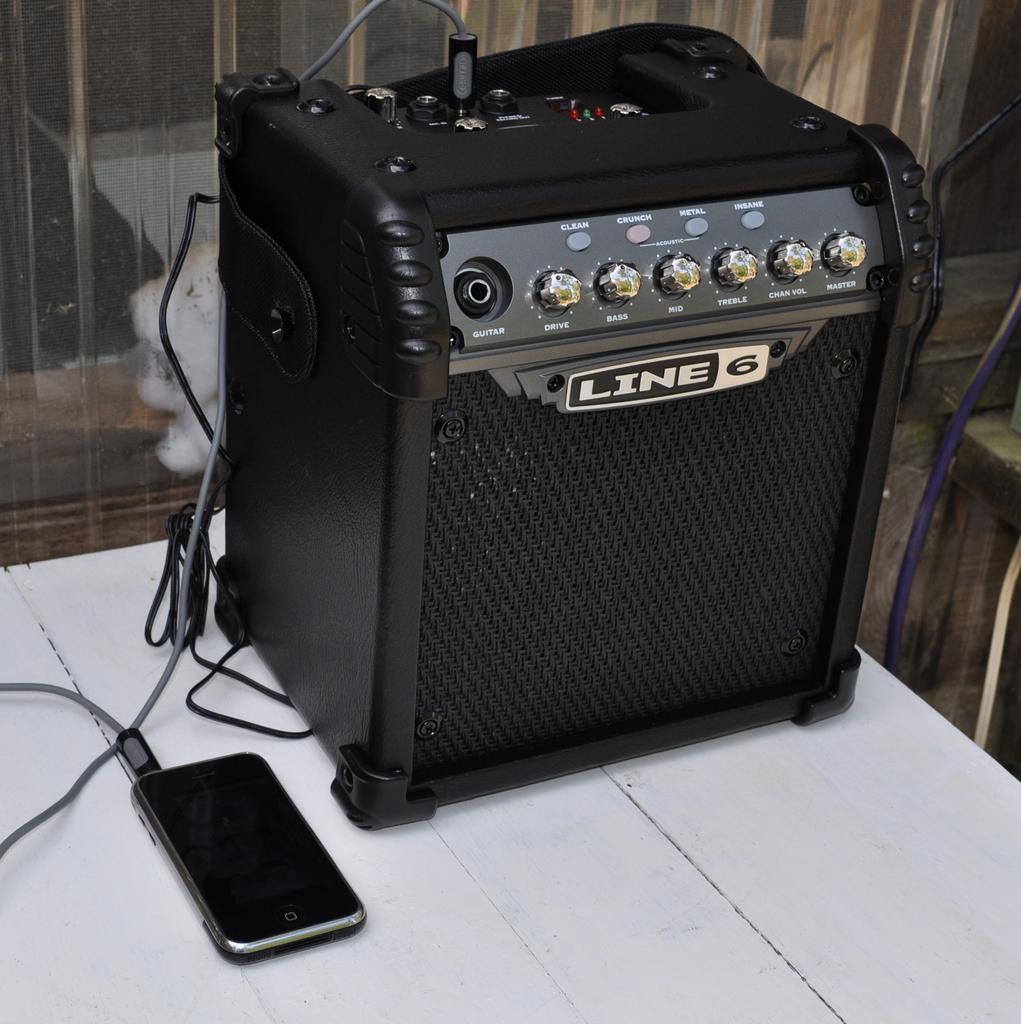Provide a one-sentence caption for the provided image. A cellphone is connected to a Line 6 amplifier. 